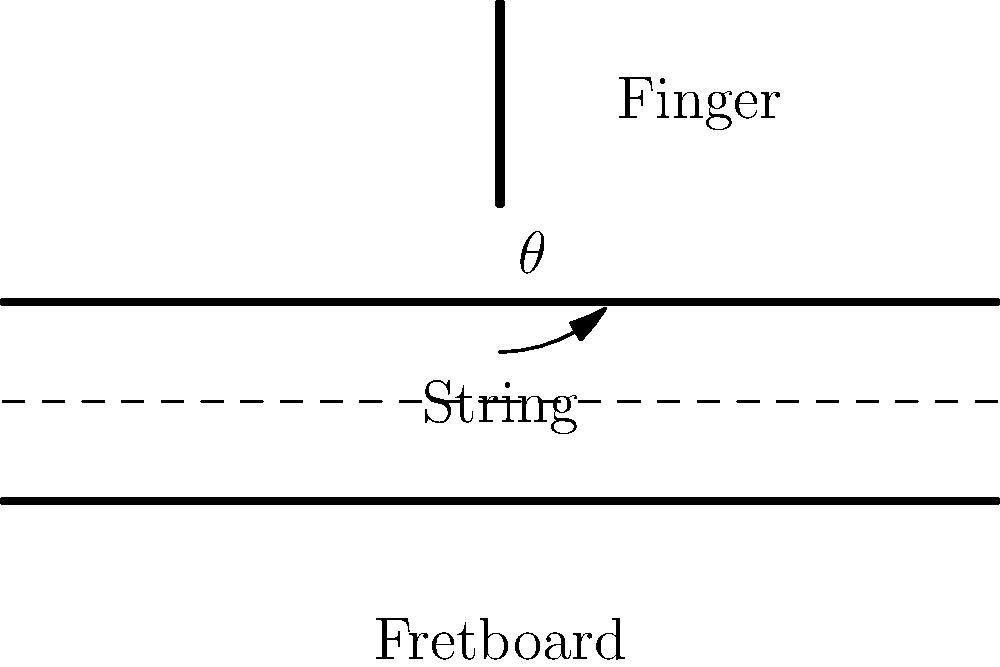In classical guitar technique, what is the optimal angle ($\theta$) between the finger and the fretboard for achieving the best string vibration and tone production? To determine the optimal angle for finger placement on the fretboard, we need to consider several factors:

1. String pressure: The finger needs to apply enough pressure to stop the string against the fret.
2. Flexibility: The angle should allow for quick and efficient movement between notes.
3. Tone quality: The angle affects the clarity and purity of the note.

The optimal angle is generally considered to be around 45 degrees for the following reasons:

1. At 45 degrees, the finger can apply sufficient pressure to the string without excessive force.
2. This angle allows for a natural hand position, reducing strain and facilitating faster movements.
3. It provides a good balance between string contact and finger flexibility.
4. The 45-degree angle allows for clean note articulation and minimizes unwanted string buzzing.

When the angle is too steep (closer to 90 degrees):
- It becomes harder to apply pressure efficiently.
- It can lead to tension in the hand and reduced speed.

When the angle is too shallow (closer to 0 degrees):
- It may not provide enough pressure to stop the string cleanly.
- It can result in muffled tones or unintended harmonics.

The 45-degree angle is a general guideline, and slight variations may occur depending on individual hand anatomy and specific musical passages. However, this angle serves as an excellent starting point for achieving optimal string vibration and tone production in classical guitar technique.
Answer: 45 degrees 